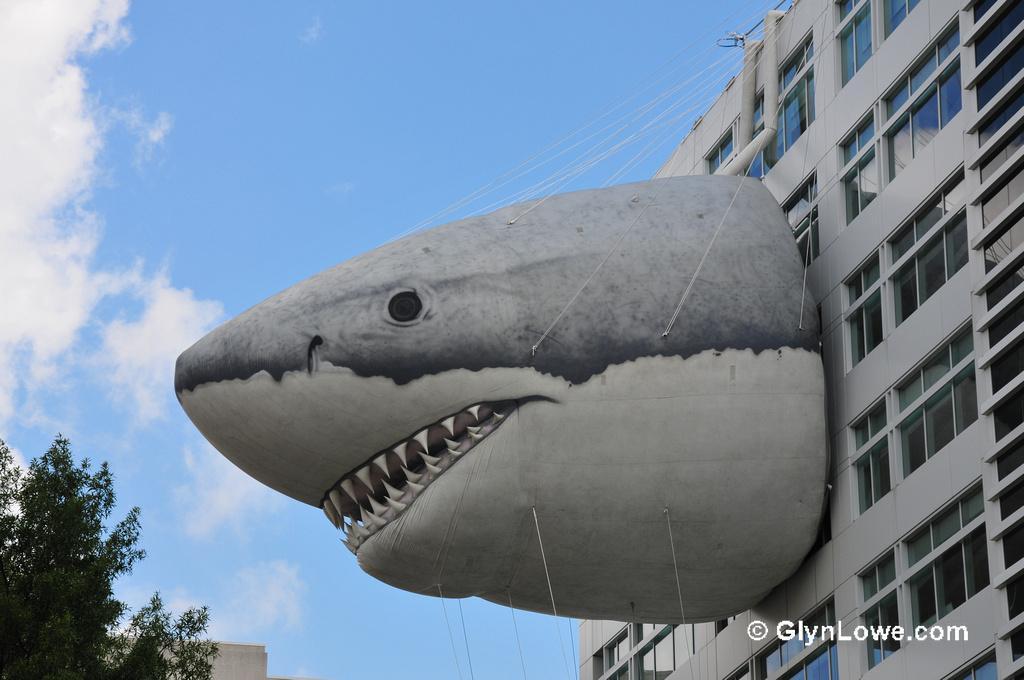Describe this image in one or two sentences. In this image we can see building. In the background there are clouds, tree, building and sky. 